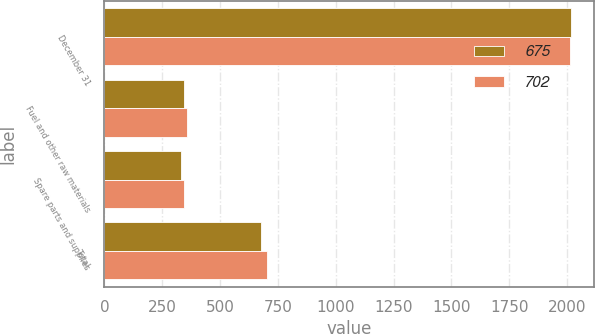<chart> <loc_0><loc_0><loc_500><loc_500><stacked_bar_chart><ecel><fcel>December 31<fcel>Fuel and other raw materials<fcel>Spare parts and supplies<fcel>Total<nl><fcel>675<fcel>2015<fcel>343<fcel>332<fcel>675<nl><fcel>702<fcel>2014<fcel>357<fcel>345<fcel>702<nl></chart> 